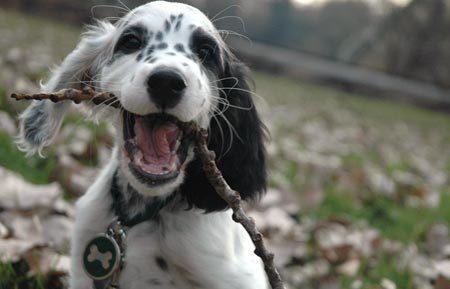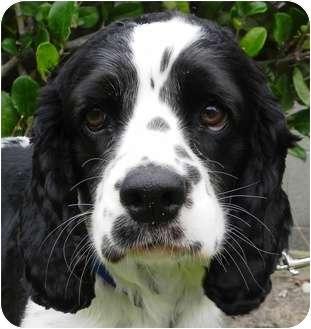The first image is the image on the left, the second image is the image on the right. Assess this claim about the two images: "The left image contains a human hand touching a black and white dog.". Correct or not? Answer yes or no. No. The first image is the image on the left, the second image is the image on the right. For the images shown, is this caption "A human is touching the dog in the image on the left." true? Answer yes or no. No. 